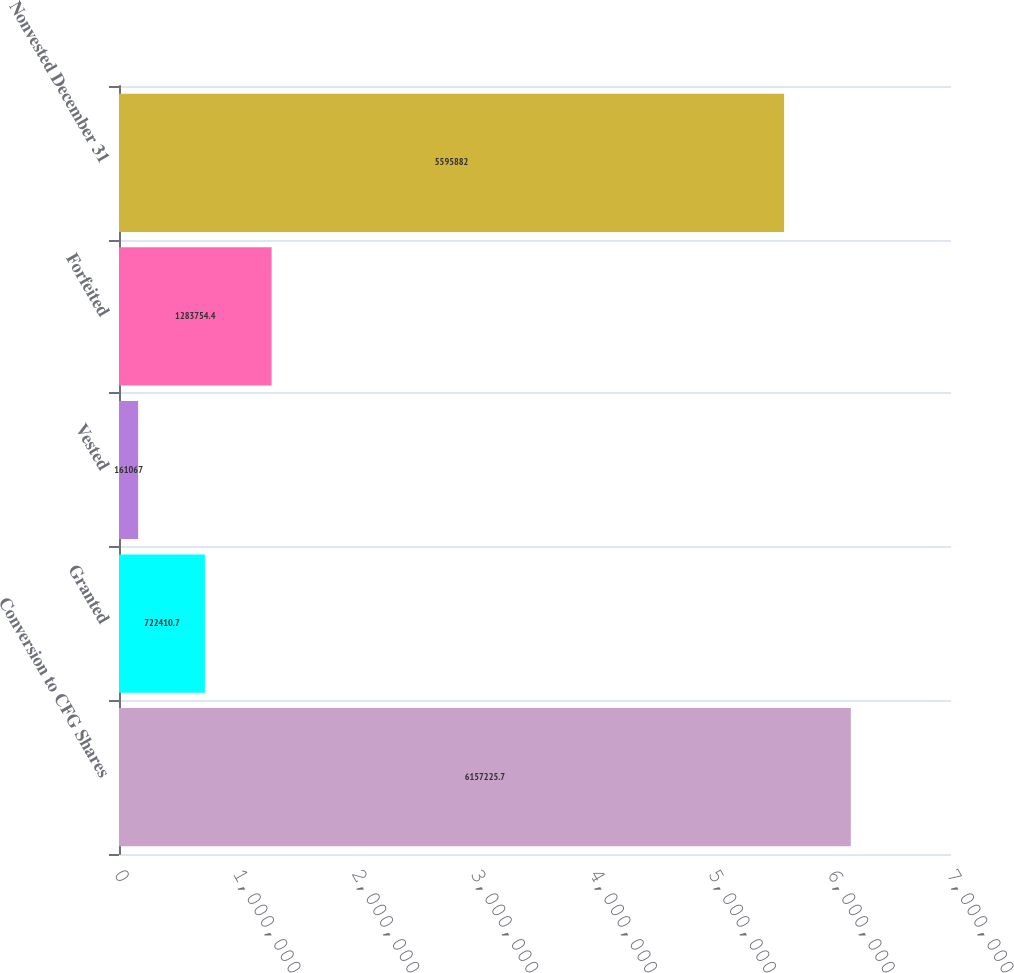Convert chart. <chart><loc_0><loc_0><loc_500><loc_500><bar_chart><fcel>Conversion to CFG Shares<fcel>Granted<fcel>Vested<fcel>Forfeited<fcel>Nonvested December 31<nl><fcel>6.15723e+06<fcel>722411<fcel>161067<fcel>1.28375e+06<fcel>5.59588e+06<nl></chart> 